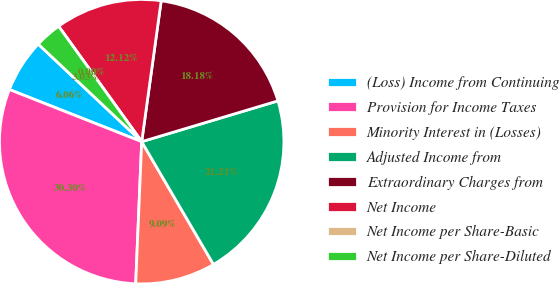<chart> <loc_0><loc_0><loc_500><loc_500><pie_chart><fcel>(Loss) Income from Continuing<fcel>Provision for Income Taxes<fcel>Minority Interest in (Losses)<fcel>Adjusted Income from<fcel>Extraordinary Charges from<fcel>Net Income<fcel>Net Income per Share-Basic<fcel>Net Income per Share-Diluted<nl><fcel>6.06%<fcel>30.3%<fcel>9.09%<fcel>21.21%<fcel>18.18%<fcel>12.12%<fcel>0.0%<fcel>3.03%<nl></chart> 